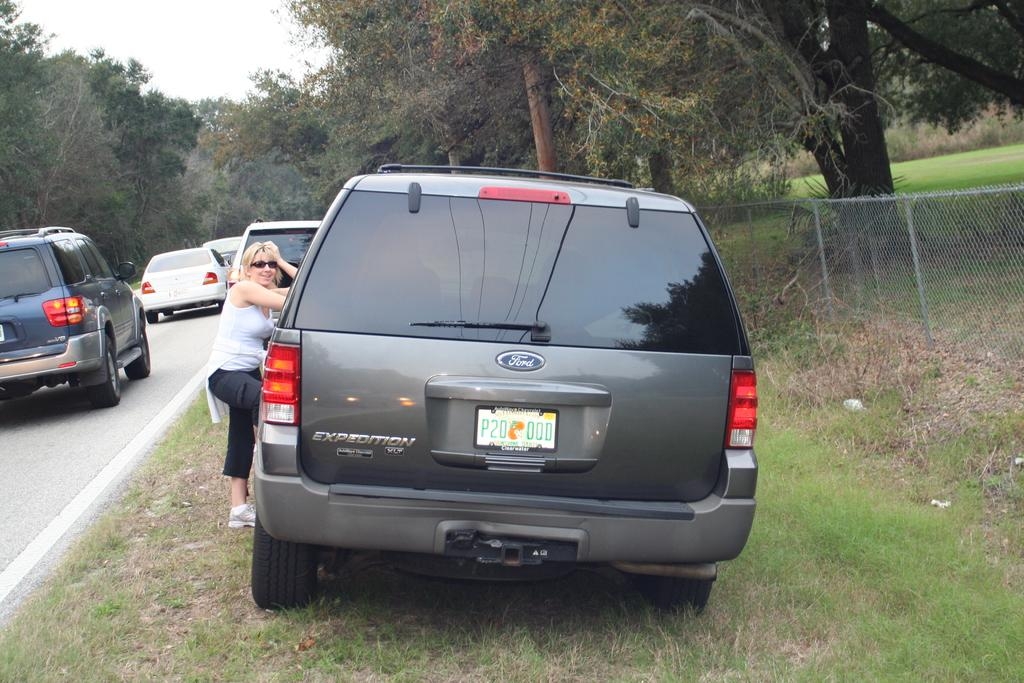<image>
Create a compact narrative representing the image presented. A Ford SUV with Florida tags reading P20 OQD. 